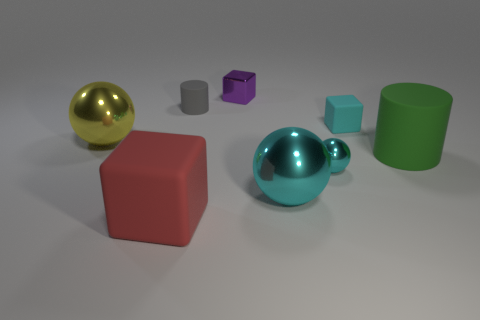Subtract all matte cubes. How many cubes are left? 1 Add 2 rubber things. How many objects exist? 10 Subtract all blue cubes. How many cyan balls are left? 2 Subtract 1 spheres. How many spheres are left? 2 Subtract all yellow balls. How many balls are left? 2 Subtract all cylinders. How many objects are left? 6 Subtract 0 blue blocks. How many objects are left? 8 Subtract all purple balls. Subtract all cyan blocks. How many balls are left? 3 Subtract all large gray metallic cylinders. Subtract all big red things. How many objects are left? 7 Add 7 tiny purple things. How many tiny purple things are left? 8 